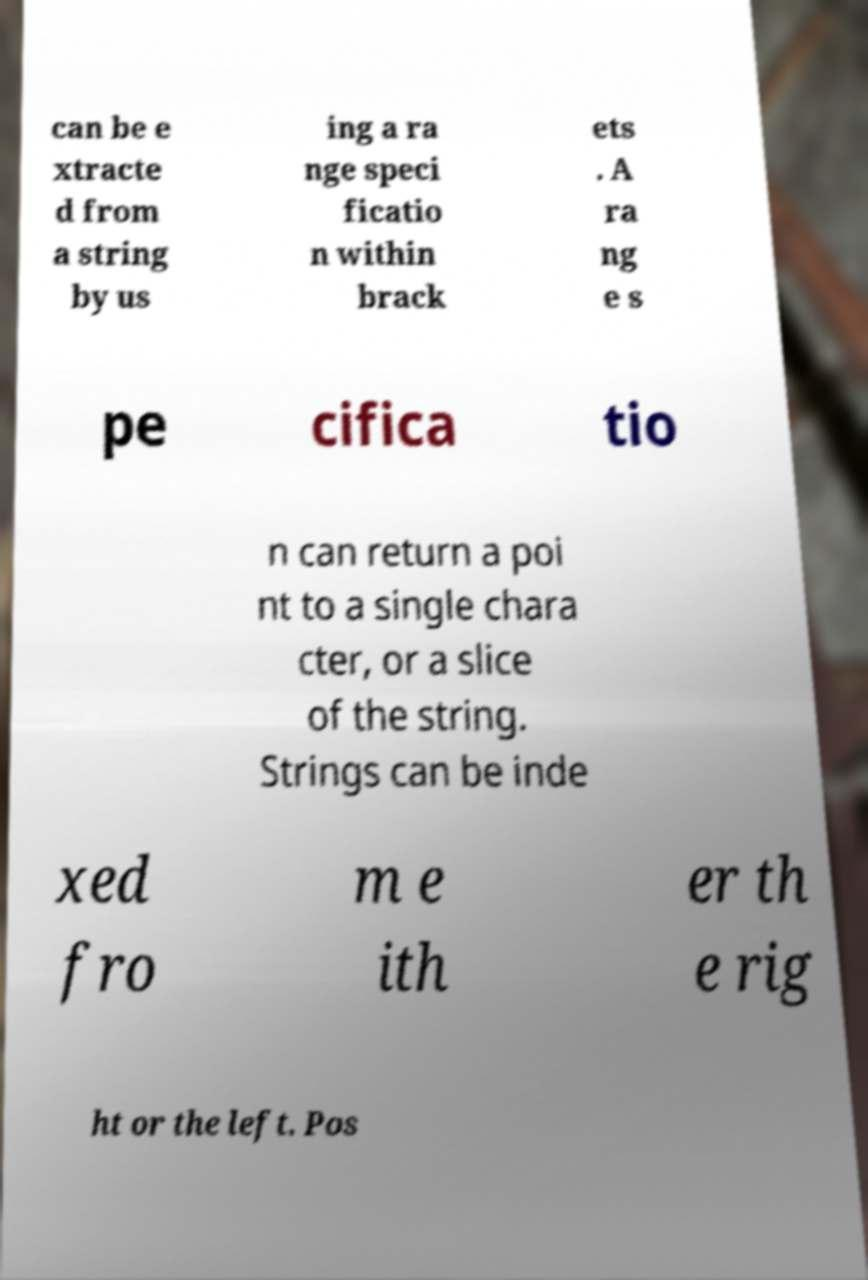Can you accurately transcribe the text from the provided image for me? can be e xtracte d from a string by us ing a ra nge speci ficatio n within brack ets . A ra ng e s pe cifica tio n can return a poi nt to a single chara cter, or a slice of the string. Strings can be inde xed fro m e ith er th e rig ht or the left. Pos 